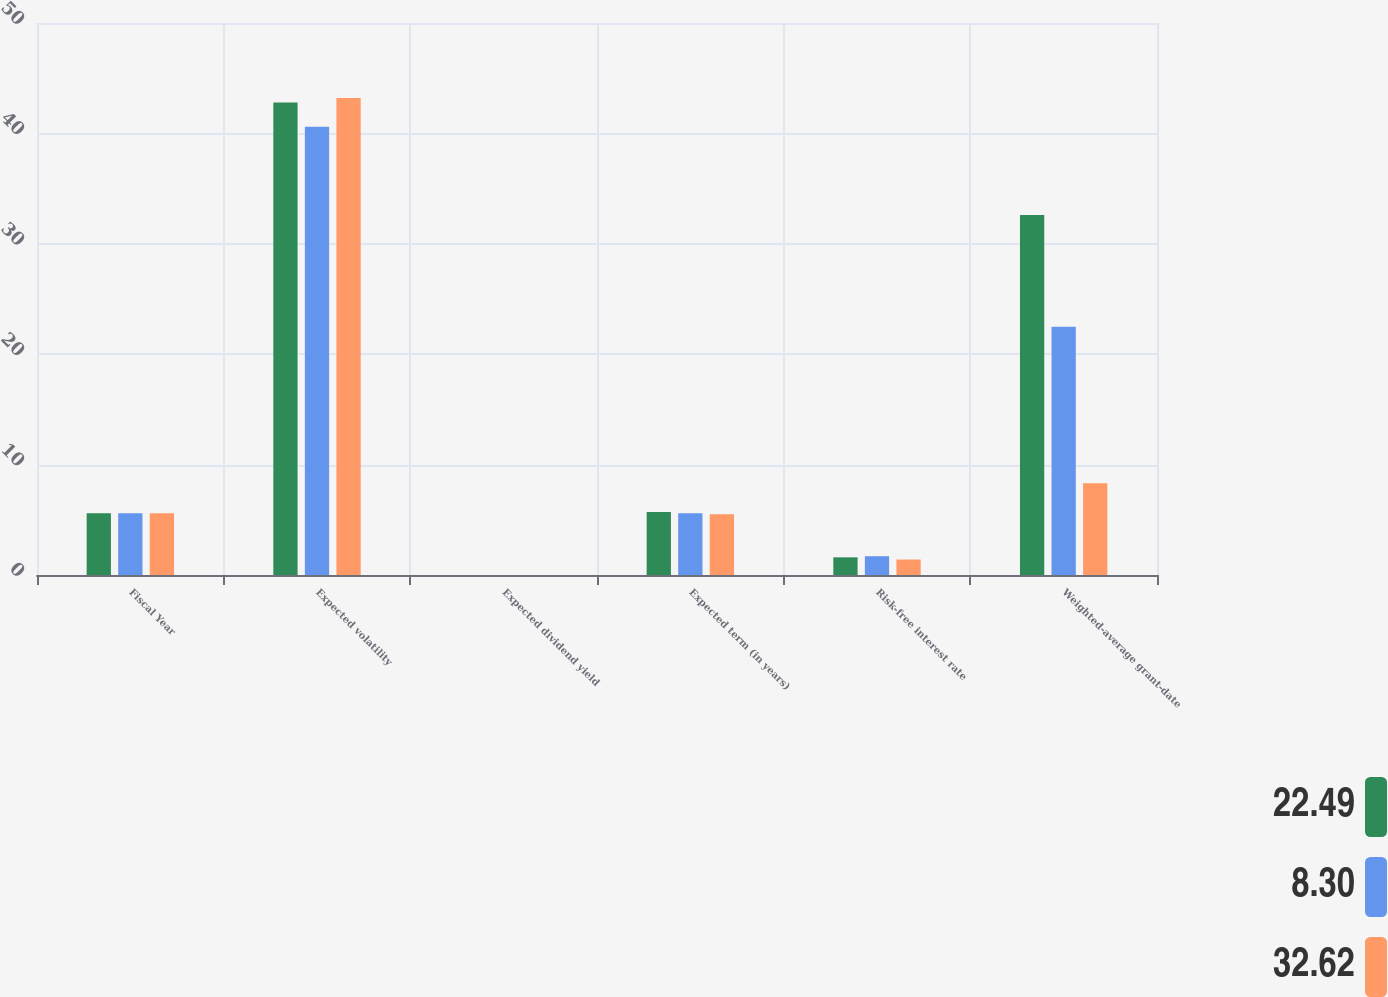<chart> <loc_0><loc_0><loc_500><loc_500><stacked_bar_chart><ecel><fcel>Fiscal Year<fcel>Expected volatility<fcel>Expected dividend yield<fcel>Expected term (in years)<fcel>Risk-free interest rate<fcel>Weighted-average grant-date<nl><fcel>22.49<fcel>5.6<fcel>42.8<fcel>0<fcel>5.7<fcel>1.6<fcel>32.62<nl><fcel>8.3<fcel>5.6<fcel>40.6<fcel>0<fcel>5.6<fcel>1.7<fcel>22.49<nl><fcel>32.62<fcel>5.6<fcel>43.2<fcel>0<fcel>5.5<fcel>1.4<fcel>8.3<nl></chart> 